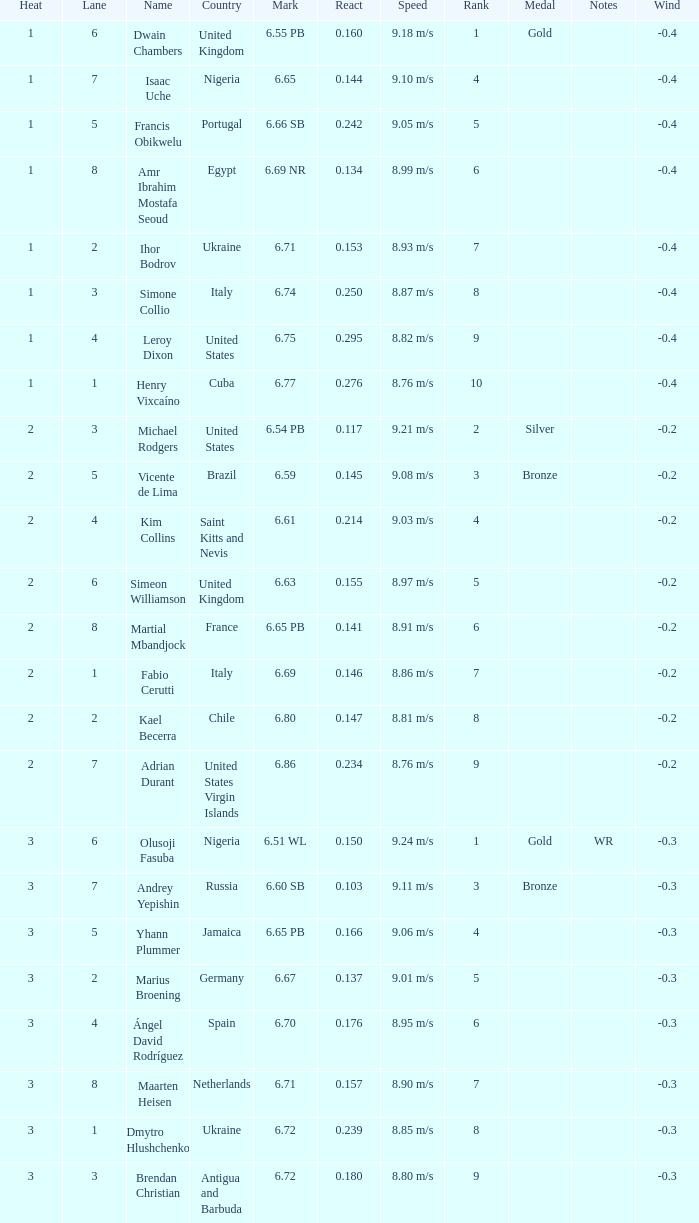166? Portugal. 